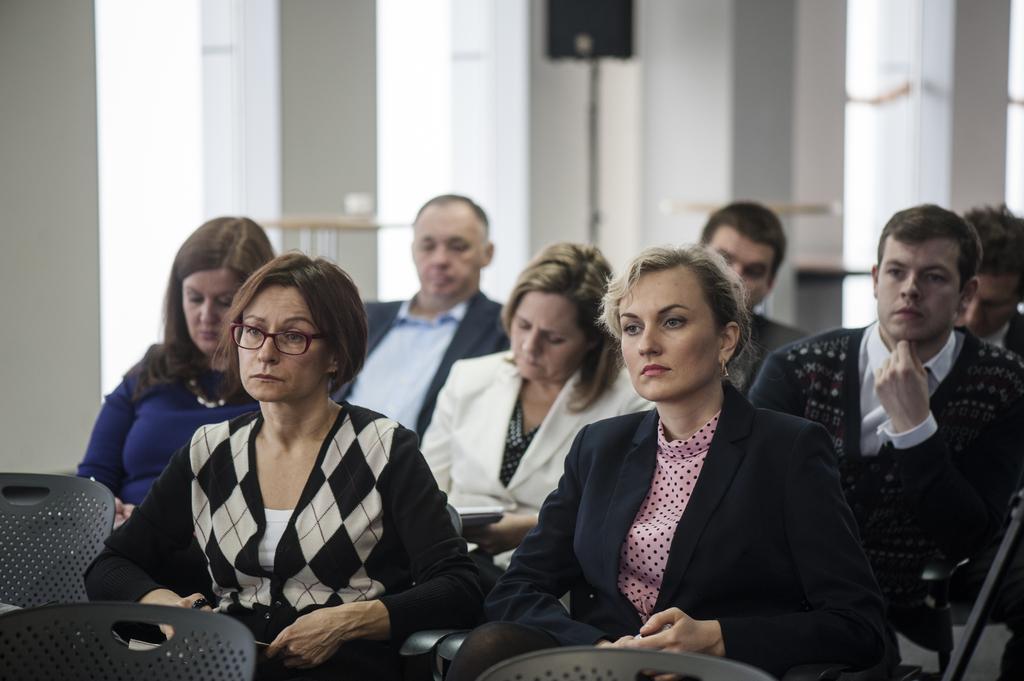How would you summarize this image in a sentence or two? In this image we can see a few people sitting on the chairs, there are few empty chairs, also we can see the wall, a speaker, and windows, the background is blurred. 